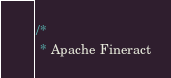Convert code to text. <code><loc_0><loc_0><loc_500><loc_500><_Java_>/*
 * Apache Fineract</code> 